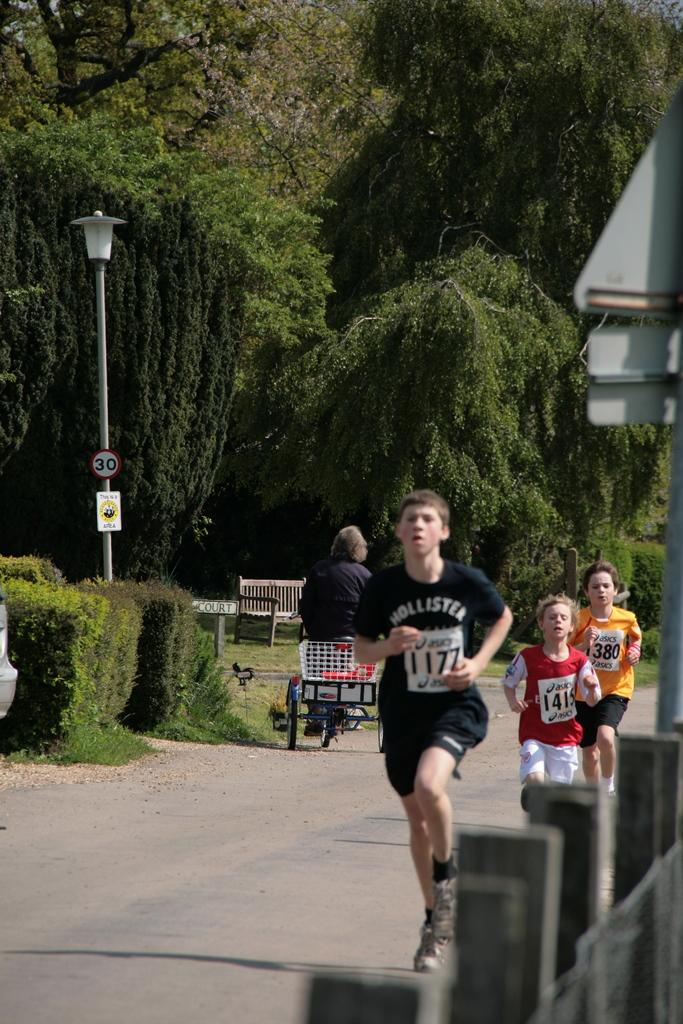What are the three persons in the image doing? The three persons in the image are running on the road. Can you describe the mode of transportation for one of the persons? There is a person riding a rickshaw in the image. What type of natural elements can be seen in the image? There are trees and plants in the image. What are some man-made objects visible in the image? There are poles, lights, boards, and a bench in the image. What type of needle is being used to sew the turkey in the image? There is no turkey or needle present in the image. What part of the stem can be seen growing from the bench in the image? There is no stem or plant growing from the bench in the image. 